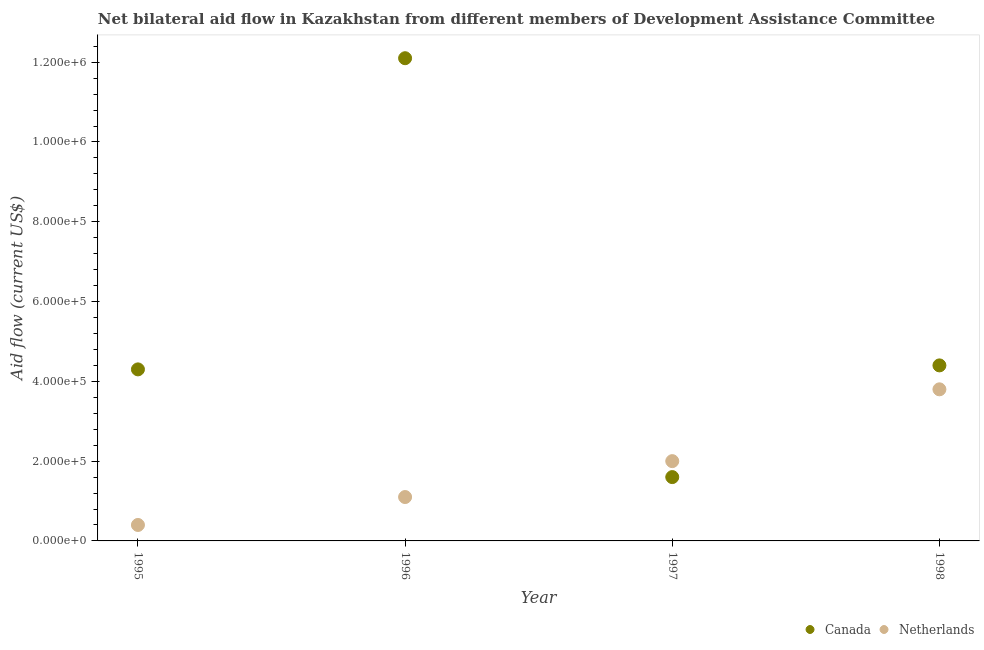What is the amount of aid given by netherlands in 1997?
Provide a succinct answer. 2.00e+05. Across all years, what is the maximum amount of aid given by canada?
Make the answer very short. 1.21e+06. Across all years, what is the minimum amount of aid given by netherlands?
Ensure brevity in your answer.  4.00e+04. What is the total amount of aid given by canada in the graph?
Give a very brief answer. 2.24e+06. What is the difference between the amount of aid given by netherlands in 1997 and that in 1998?
Offer a very short reply. -1.80e+05. What is the difference between the amount of aid given by netherlands in 1997 and the amount of aid given by canada in 1996?
Your answer should be very brief. -1.01e+06. What is the average amount of aid given by netherlands per year?
Provide a succinct answer. 1.82e+05. In the year 1995, what is the difference between the amount of aid given by netherlands and amount of aid given by canada?
Provide a short and direct response. -3.90e+05. In how many years, is the amount of aid given by netherlands greater than 40000 US$?
Your answer should be compact. 3. What is the ratio of the amount of aid given by canada in 1996 to that in 1998?
Give a very brief answer. 2.75. Is the amount of aid given by canada in 1995 less than that in 1996?
Your answer should be very brief. Yes. Is the difference between the amount of aid given by canada in 1996 and 1998 greater than the difference between the amount of aid given by netherlands in 1996 and 1998?
Make the answer very short. Yes. What is the difference between the highest and the second highest amount of aid given by canada?
Your answer should be compact. 7.70e+05. What is the difference between the highest and the lowest amount of aid given by netherlands?
Your answer should be very brief. 3.40e+05. In how many years, is the amount of aid given by netherlands greater than the average amount of aid given by netherlands taken over all years?
Offer a terse response. 2. Does the amount of aid given by canada monotonically increase over the years?
Give a very brief answer. No. Is the amount of aid given by netherlands strictly greater than the amount of aid given by canada over the years?
Keep it short and to the point. No. Is the amount of aid given by netherlands strictly less than the amount of aid given by canada over the years?
Your answer should be compact. No. What is the difference between two consecutive major ticks on the Y-axis?
Offer a very short reply. 2.00e+05. Are the values on the major ticks of Y-axis written in scientific E-notation?
Keep it short and to the point. Yes. Does the graph contain any zero values?
Your answer should be very brief. No. How many legend labels are there?
Keep it short and to the point. 2. What is the title of the graph?
Provide a short and direct response. Net bilateral aid flow in Kazakhstan from different members of Development Assistance Committee. What is the label or title of the Y-axis?
Your response must be concise. Aid flow (current US$). What is the Aid flow (current US$) in Netherlands in 1995?
Your answer should be very brief. 4.00e+04. What is the Aid flow (current US$) in Canada in 1996?
Keep it short and to the point. 1.21e+06. What is the Aid flow (current US$) in Canada in 1998?
Ensure brevity in your answer.  4.40e+05. Across all years, what is the maximum Aid flow (current US$) of Canada?
Keep it short and to the point. 1.21e+06. What is the total Aid flow (current US$) of Canada in the graph?
Your response must be concise. 2.24e+06. What is the total Aid flow (current US$) of Netherlands in the graph?
Offer a very short reply. 7.30e+05. What is the difference between the Aid flow (current US$) in Canada in 1995 and that in 1996?
Ensure brevity in your answer.  -7.80e+05. What is the difference between the Aid flow (current US$) of Netherlands in 1995 and that in 1996?
Ensure brevity in your answer.  -7.00e+04. What is the difference between the Aid flow (current US$) of Netherlands in 1995 and that in 1997?
Provide a succinct answer. -1.60e+05. What is the difference between the Aid flow (current US$) of Canada in 1996 and that in 1997?
Make the answer very short. 1.05e+06. What is the difference between the Aid flow (current US$) in Netherlands in 1996 and that in 1997?
Ensure brevity in your answer.  -9.00e+04. What is the difference between the Aid flow (current US$) in Canada in 1996 and that in 1998?
Offer a very short reply. 7.70e+05. What is the difference between the Aid flow (current US$) of Netherlands in 1996 and that in 1998?
Your answer should be compact. -2.70e+05. What is the difference between the Aid flow (current US$) in Canada in 1997 and that in 1998?
Give a very brief answer. -2.80e+05. What is the difference between the Aid flow (current US$) in Canada in 1995 and the Aid flow (current US$) in Netherlands in 1997?
Your answer should be very brief. 2.30e+05. What is the difference between the Aid flow (current US$) in Canada in 1996 and the Aid flow (current US$) in Netherlands in 1997?
Provide a short and direct response. 1.01e+06. What is the difference between the Aid flow (current US$) in Canada in 1996 and the Aid flow (current US$) in Netherlands in 1998?
Your answer should be compact. 8.30e+05. What is the difference between the Aid flow (current US$) in Canada in 1997 and the Aid flow (current US$) in Netherlands in 1998?
Provide a succinct answer. -2.20e+05. What is the average Aid flow (current US$) of Canada per year?
Ensure brevity in your answer.  5.60e+05. What is the average Aid flow (current US$) in Netherlands per year?
Give a very brief answer. 1.82e+05. In the year 1995, what is the difference between the Aid flow (current US$) of Canada and Aid flow (current US$) of Netherlands?
Your answer should be compact. 3.90e+05. In the year 1996, what is the difference between the Aid flow (current US$) in Canada and Aid flow (current US$) in Netherlands?
Provide a short and direct response. 1.10e+06. In the year 1998, what is the difference between the Aid flow (current US$) of Canada and Aid flow (current US$) of Netherlands?
Your answer should be compact. 6.00e+04. What is the ratio of the Aid flow (current US$) in Canada in 1995 to that in 1996?
Your response must be concise. 0.36. What is the ratio of the Aid flow (current US$) in Netherlands in 1995 to that in 1996?
Give a very brief answer. 0.36. What is the ratio of the Aid flow (current US$) of Canada in 1995 to that in 1997?
Your response must be concise. 2.69. What is the ratio of the Aid flow (current US$) in Canada in 1995 to that in 1998?
Your answer should be compact. 0.98. What is the ratio of the Aid flow (current US$) in Netherlands in 1995 to that in 1998?
Keep it short and to the point. 0.11. What is the ratio of the Aid flow (current US$) of Canada in 1996 to that in 1997?
Provide a succinct answer. 7.56. What is the ratio of the Aid flow (current US$) of Netherlands in 1996 to that in 1997?
Provide a succinct answer. 0.55. What is the ratio of the Aid flow (current US$) in Canada in 1996 to that in 1998?
Your answer should be very brief. 2.75. What is the ratio of the Aid flow (current US$) in Netherlands in 1996 to that in 1998?
Your response must be concise. 0.29. What is the ratio of the Aid flow (current US$) in Canada in 1997 to that in 1998?
Offer a terse response. 0.36. What is the ratio of the Aid flow (current US$) of Netherlands in 1997 to that in 1998?
Give a very brief answer. 0.53. What is the difference between the highest and the second highest Aid flow (current US$) in Canada?
Offer a very short reply. 7.70e+05. What is the difference between the highest and the second highest Aid flow (current US$) of Netherlands?
Your answer should be very brief. 1.80e+05. What is the difference between the highest and the lowest Aid flow (current US$) in Canada?
Offer a terse response. 1.05e+06. 